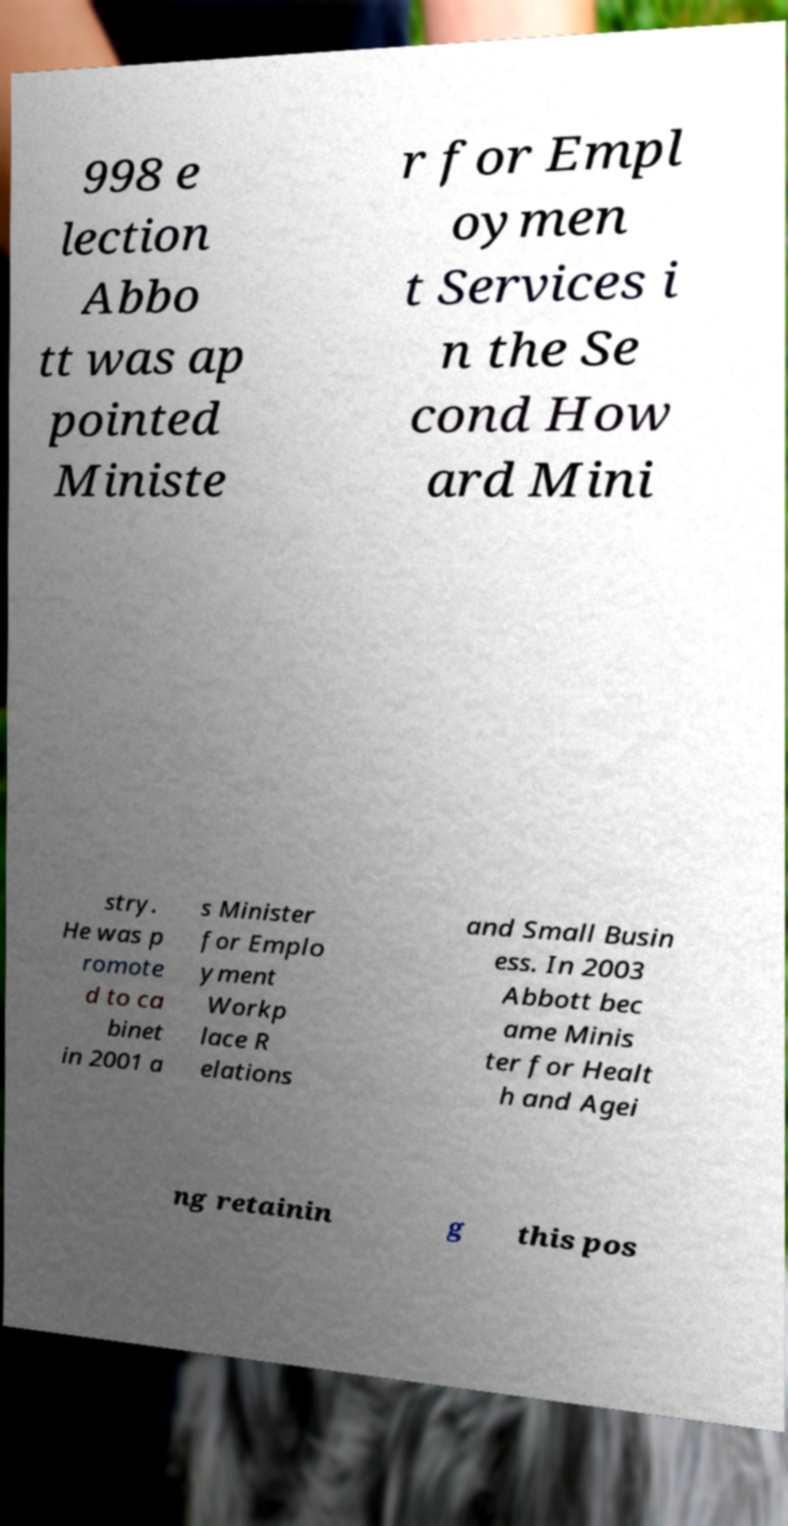Please read and relay the text visible in this image. What does it say? 998 e lection Abbo tt was ap pointed Ministe r for Empl oymen t Services i n the Se cond How ard Mini stry. He was p romote d to ca binet in 2001 a s Minister for Emplo yment Workp lace R elations and Small Busin ess. In 2003 Abbott bec ame Minis ter for Healt h and Agei ng retainin g this pos 